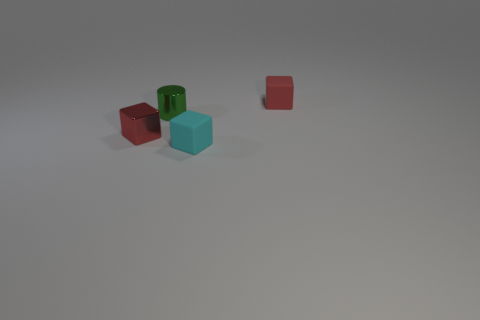Add 4 tiny metal cylinders. How many objects exist? 8 Subtract all cylinders. How many objects are left? 3 Subtract all small red things. Subtract all small matte objects. How many objects are left? 0 Add 2 small red things. How many small red things are left? 4 Add 4 tiny metal balls. How many tiny metal balls exist? 4 Subtract 0 blue cubes. How many objects are left? 4 